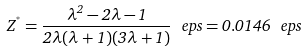Convert formula to latex. <formula><loc_0><loc_0><loc_500><loc_500>Z ^ { ^ { * } } = \frac { \lambda ^ { 2 } - 2 \lambda - 1 } { 2 \lambda ( \lambda + 1 ) ( 3 \lambda + 1 ) } \ e p s = 0 . 0 1 4 6 \ e p s</formula> 